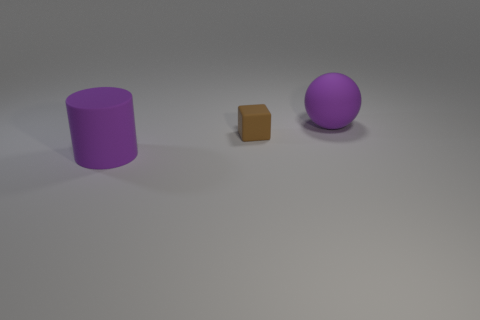Is there any other thing that is the same shape as the brown matte thing?
Your answer should be compact. No. Is there anything else that is the same size as the brown rubber object?
Provide a succinct answer. No. Is the size of the matte ball the same as the brown object?
Ensure brevity in your answer.  No. What number of objects are purple objects behind the purple cylinder or tiny shiny blocks?
Your answer should be compact. 1. The purple object that is left of the object that is to the right of the rubber cube is what shape?
Your response must be concise. Cylinder. Does the rubber ball have the same size as the purple object that is in front of the small brown matte block?
Your answer should be very brief. Yes. What number of big purple objects are in front of the small brown object and on the right side of the purple cylinder?
Offer a very short reply. 0. What is the material of the purple thing that is the same size as the matte sphere?
Ensure brevity in your answer.  Rubber. There is a rubber object in front of the tiny block; does it have the same size as the sphere that is behind the tiny brown rubber cube?
Provide a short and direct response. Yes. Are there any big purple spheres left of the brown matte cube?
Make the answer very short. No. 